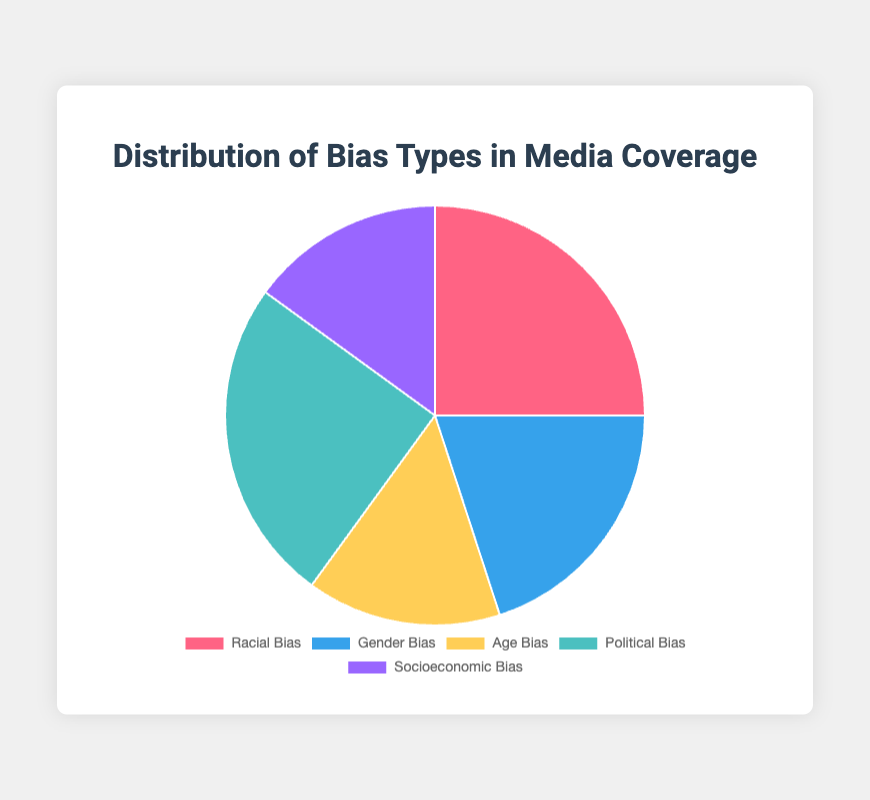Which bias type is most prevalent in media coverage? To determine this, we observe the pie chart for the largest segment. The segments for "Racial Bias" and "Political Bias" both cover 25% of the chart, which are the largest.
Answer: Racial Bias and Political Bias Which bias types have equal representation in media coverage? From the data, both "Age Bias" and "Socioeconomic Bias" account for 15% each of the total pie chart.
Answer: Age Bias and Socioeconomic Bias What is the combined percentage of Racial Bias and Political Bias in media coverage? By adding the percentages of "Racial Bias" (25%) and "Political Bias" (25%), we get 25% + 25% = 50%.
Answer: 50% Is the percentage of Gender Bias greater than that of Age Bias? Looking at the pie chart, "Gender Bias" is 20% and "Age Bias" is 15%. Since 20% > 15%, Gender Bias is greater.
Answer: Yes What is the difference in percentage between the highest and lowest bias types? The highest percentages are "Racial Bias" and "Political Bias" at 25%, and the lowest are "Age Bias" and "Socioeconomic Bias" at 15%. The difference is 25% - 15% = 10%.
Answer: 10% What is the visual color representing Socioeconomic Bias in the chart? By identifying the segment color in the chart's legend corresponding to "Socioeconomic Bias", we see it is represented by purple color.
Answer: Purple What is the average percentage of all bias types in media coverage? Sum all percentages: 25 + 20 + 15 + 25 + 15 = 100. Divide by the number of bias types, which is 5. So, 100 / 5 = 20%.
Answer: 20% Is the percentage of Age Bias equal to that of Socioeconomic Bias? From the chart, both "Age Bias" and "Socioeconomic Bias" share the same percentage of 15%.
Answer: Yes Which bias types together constitute exactly half of the media coverage? Adding "Racial Bias" (25%) and "Political Bias" (25%) equals 25% + 25% = 50%. No other combination sums to exactly 50%.
Answer: Racial Bias and Political Bias Describe the visual representation of Gender Bias. The pie chart shows Gender Bias in a segment colored blue, representing 20% of the total distribution.
Answer: 20% Blue 